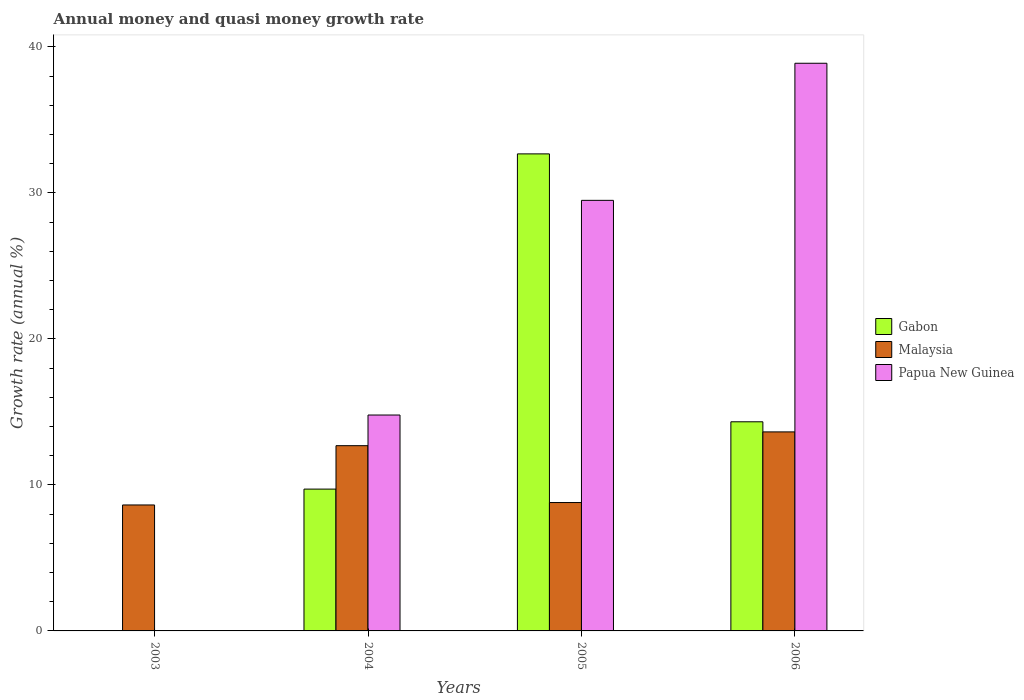Are the number of bars per tick equal to the number of legend labels?
Your answer should be compact. No. How many bars are there on the 3rd tick from the left?
Give a very brief answer. 3. What is the label of the 1st group of bars from the left?
Give a very brief answer. 2003. What is the growth rate in Malaysia in 2005?
Make the answer very short. 8.79. Across all years, what is the maximum growth rate in Papua New Guinea?
Your answer should be very brief. 38.88. What is the total growth rate in Gabon in the graph?
Provide a short and direct response. 56.71. What is the difference between the growth rate in Gabon in 2004 and that in 2005?
Give a very brief answer. -22.96. What is the difference between the growth rate in Papua New Guinea in 2003 and the growth rate in Malaysia in 2006?
Offer a terse response. -13.63. What is the average growth rate in Malaysia per year?
Your response must be concise. 10.93. In the year 2004, what is the difference between the growth rate in Malaysia and growth rate in Papua New Guinea?
Keep it short and to the point. -2.1. In how many years, is the growth rate in Papua New Guinea greater than 18 %?
Your answer should be compact. 2. What is the ratio of the growth rate in Malaysia in 2004 to that in 2006?
Provide a short and direct response. 0.93. Is the difference between the growth rate in Malaysia in 2004 and 2005 greater than the difference between the growth rate in Papua New Guinea in 2004 and 2005?
Give a very brief answer. Yes. What is the difference between the highest and the second highest growth rate in Papua New Guinea?
Ensure brevity in your answer.  9.39. What is the difference between the highest and the lowest growth rate in Papua New Guinea?
Your response must be concise. 38.88. Is the sum of the growth rate in Papua New Guinea in 2004 and 2005 greater than the maximum growth rate in Gabon across all years?
Give a very brief answer. Yes. Does the graph contain grids?
Offer a terse response. No. How are the legend labels stacked?
Ensure brevity in your answer.  Vertical. What is the title of the graph?
Provide a succinct answer. Annual money and quasi money growth rate. Does "Argentina" appear as one of the legend labels in the graph?
Make the answer very short. No. What is the label or title of the X-axis?
Make the answer very short. Years. What is the label or title of the Y-axis?
Your answer should be very brief. Growth rate (annual %). What is the Growth rate (annual %) in Gabon in 2003?
Give a very brief answer. 0. What is the Growth rate (annual %) in Malaysia in 2003?
Ensure brevity in your answer.  8.63. What is the Growth rate (annual %) of Gabon in 2004?
Offer a terse response. 9.71. What is the Growth rate (annual %) of Malaysia in 2004?
Ensure brevity in your answer.  12.69. What is the Growth rate (annual %) in Papua New Guinea in 2004?
Keep it short and to the point. 14.79. What is the Growth rate (annual %) of Gabon in 2005?
Provide a succinct answer. 32.67. What is the Growth rate (annual %) in Malaysia in 2005?
Make the answer very short. 8.79. What is the Growth rate (annual %) of Papua New Guinea in 2005?
Provide a short and direct response. 29.49. What is the Growth rate (annual %) of Gabon in 2006?
Your answer should be compact. 14.32. What is the Growth rate (annual %) of Malaysia in 2006?
Your response must be concise. 13.63. What is the Growth rate (annual %) in Papua New Guinea in 2006?
Your answer should be very brief. 38.88. Across all years, what is the maximum Growth rate (annual %) in Gabon?
Provide a short and direct response. 32.67. Across all years, what is the maximum Growth rate (annual %) in Malaysia?
Offer a terse response. 13.63. Across all years, what is the maximum Growth rate (annual %) in Papua New Guinea?
Your answer should be very brief. 38.88. Across all years, what is the minimum Growth rate (annual %) of Malaysia?
Your response must be concise. 8.63. What is the total Growth rate (annual %) of Gabon in the graph?
Your answer should be very brief. 56.71. What is the total Growth rate (annual %) of Malaysia in the graph?
Keep it short and to the point. 43.74. What is the total Growth rate (annual %) in Papua New Guinea in the graph?
Offer a very short reply. 83.16. What is the difference between the Growth rate (annual %) in Malaysia in 2003 and that in 2004?
Give a very brief answer. -4.06. What is the difference between the Growth rate (annual %) of Malaysia in 2003 and that in 2005?
Give a very brief answer. -0.17. What is the difference between the Growth rate (annual %) in Malaysia in 2003 and that in 2006?
Keep it short and to the point. -5. What is the difference between the Growth rate (annual %) of Gabon in 2004 and that in 2005?
Ensure brevity in your answer.  -22.96. What is the difference between the Growth rate (annual %) in Malaysia in 2004 and that in 2005?
Keep it short and to the point. 3.89. What is the difference between the Growth rate (annual %) of Papua New Guinea in 2004 and that in 2005?
Provide a succinct answer. -14.7. What is the difference between the Growth rate (annual %) in Gabon in 2004 and that in 2006?
Make the answer very short. -4.61. What is the difference between the Growth rate (annual %) of Malaysia in 2004 and that in 2006?
Make the answer very short. -0.94. What is the difference between the Growth rate (annual %) of Papua New Guinea in 2004 and that in 2006?
Ensure brevity in your answer.  -24.09. What is the difference between the Growth rate (annual %) in Gabon in 2005 and that in 2006?
Offer a very short reply. 18.35. What is the difference between the Growth rate (annual %) in Malaysia in 2005 and that in 2006?
Your response must be concise. -4.84. What is the difference between the Growth rate (annual %) in Papua New Guinea in 2005 and that in 2006?
Ensure brevity in your answer.  -9.39. What is the difference between the Growth rate (annual %) in Malaysia in 2003 and the Growth rate (annual %) in Papua New Guinea in 2004?
Provide a succinct answer. -6.16. What is the difference between the Growth rate (annual %) in Malaysia in 2003 and the Growth rate (annual %) in Papua New Guinea in 2005?
Provide a short and direct response. -20.86. What is the difference between the Growth rate (annual %) of Malaysia in 2003 and the Growth rate (annual %) of Papua New Guinea in 2006?
Your answer should be compact. -30.25. What is the difference between the Growth rate (annual %) of Gabon in 2004 and the Growth rate (annual %) of Malaysia in 2005?
Give a very brief answer. 0.92. What is the difference between the Growth rate (annual %) in Gabon in 2004 and the Growth rate (annual %) in Papua New Guinea in 2005?
Give a very brief answer. -19.78. What is the difference between the Growth rate (annual %) in Malaysia in 2004 and the Growth rate (annual %) in Papua New Guinea in 2005?
Ensure brevity in your answer.  -16.8. What is the difference between the Growth rate (annual %) in Gabon in 2004 and the Growth rate (annual %) in Malaysia in 2006?
Make the answer very short. -3.92. What is the difference between the Growth rate (annual %) of Gabon in 2004 and the Growth rate (annual %) of Papua New Guinea in 2006?
Your answer should be very brief. -29.17. What is the difference between the Growth rate (annual %) in Malaysia in 2004 and the Growth rate (annual %) in Papua New Guinea in 2006?
Keep it short and to the point. -26.19. What is the difference between the Growth rate (annual %) of Gabon in 2005 and the Growth rate (annual %) of Malaysia in 2006?
Give a very brief answer. 19.04. What is the difference between the Growth rate (annual %) in Gabon in 2005 and the Growth rate (annual %) in Papua New Guinea in 2006?
Ensure brevity in your answer.  -6.21. What is the difference between the Growth rate (annual %) of Malaysia in 2005 and the Growth rate (annual %) of Papua New Guinea in 2006?
Keep it short and to the point. -30.09. What is the average Growth rate (annual %) in Gabon per year?
Provide a short and direct response. 14.18. What is the average Growth rate (annual %) of Malaysia per year?
Provide a short and direct response. 10.93. What is the average Growth rate (annual %) in Papua New Guinea per year?
Provide a short and direct response. 20.79. In the year 2004, what is the difference between the Growth rate (annual %) in Gabon and Growth rate (annual %) in Malaysia?
Make the answer very short. -2.97. In the year 2004, what is the difference between the Growth rate (annual %) in Gabon and Growth rate (annual %) in Papua New Guinea?
Make the answer very short. -5.07. In the year 2004, what is the difference between the Growth rate (annual %) of Malaysia and Growth rate (annual %) of Papua New Guinea?
Your answer should be compact. -2.1. In the year 2005, what is the difference between the Growth rate (annual %) of Gabon and Growth rate (annual %) of Malaysia?
Keep it short and to the point. 23.88. In the year 2005, what is the difference between the Growth rate (annual %) of Gabon and Growth rate (annual %) of Papua New Guinea?
Your response must be concise. 3.18. In the year 2005, what is the difference between the Growth rate (annual %) in Malaysia and Growth rate (annual %) in Papua New Guinea?
Provide a short and direct response. -20.7. In the year 2006, what is the difference between the Growth rate (annual %) of Gabon and Growth rate (annual %) of Malaysia?
Offer a very short reply. 0.69. In the year 2006, what is the difference between the Growth rate (annual %) of Gabon and Growth rate (annual %) of Papua New Guinea?
Provide a short and direct response. -24.56. In the year 2006, what is the difference between the Growth rate (annual %) of Malaysia and Growth rate (annual %) of Papua New Guinea?
Provide a succinct answer. -25.25. What is the ratio of the Growth rate (annual %) in Malaysia in 2003 to that in 2004?
Keep it short and to the point. 0.68. What is the ratio of the Growth rate (annual %) in Malaysia in 2003 to that in 2005?
Make the answer very short. 0.98. What is the ratio of the Growth rate (annual %) of Malaysia in 2003 to that in 2006?
Offer a very short reply. 0.63. What is the ratio of the Growth rate (annual %) of Gabon in 2004 to that in 2005?
Keep it short and to the point. 0.3. What is the ratio of the Growth rate (annual %) of Malaysia in 2004 to that in 2005?
Give a very brief answer. 1.44. What is the ratio of the Growth rate (annual %) of Papua New Guinea in 2004 to that in 2005?
Offer a terse response. 0.5. What is the ratio of the Growth rate (annual %) in Gabon in 2004 to that in 2006?
Your answer should be very brief. 0.68. What is the ratio of the Growth rate (annual %) in Malaysia in 2004 to that in 2006?
Give a very brief answer. 0.93. What is the ratio of the Growth rate (annual %) of Papua New Guinea in 2004 to that in 2006?
Keep it short and to the point. 0.38. What is the ratio of the Growth rate (annual %) of Gabon in 2005 to that in 2006?
Provide a short and direct response. 2.28. What is the ratio of the Growth rate (annual %) in Malaysia in 2005 to that in 2006?
Offer a terse response. 0.65. What is the ratio of the Growth rate (annual %) of Papua New Guinea in 2005 to that in 2006?
Your answer should be compact. 0.76. What is the difference between the highest and the second highest Growth rate (annual %) of Gabon?
Provide a succinct answer. 18.35. What is the difference between the highest and the second highest Growth rate (annual %) of Malaysia?
Your answer should be very brief. 0.94. What is the difference between the highest and the second highest Growth rate (annual %) of Papua New Guinea?
Keep it short and to the point. 9.39. What is the difference between the highest and the lowest Growth rate (annual %) in Gabon?
Offer a very short reply. 32.67. What is the difference between the highest and the lowest Growth rate (annual %) of Malaysia?
Ensure brevity in your answer.  5. What is the difference between the highest and the lowest Growth rate (annual %) in Papua New Guinea?
Your response must be concise. 38.88. 